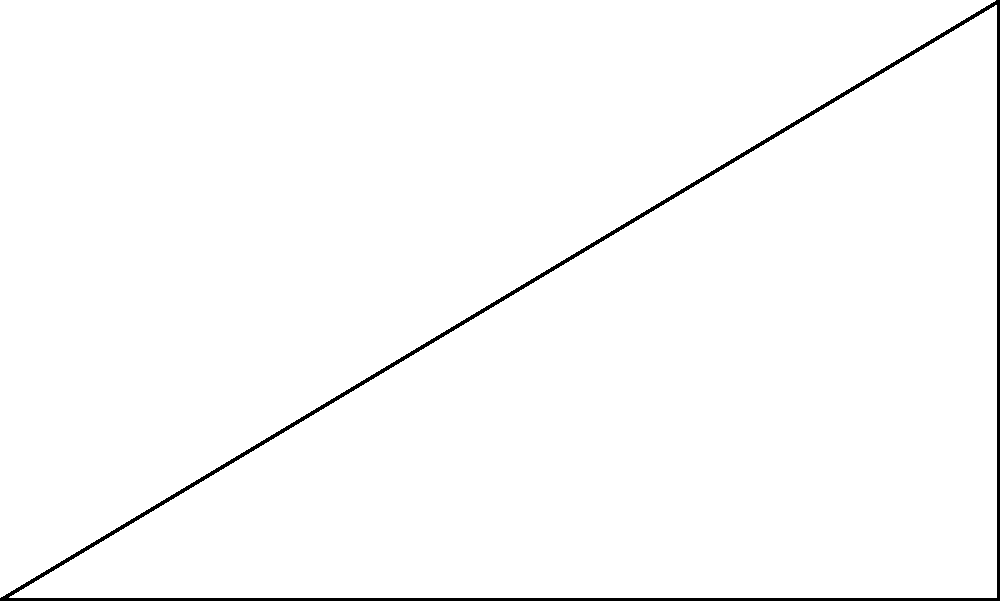You're visiting a location from a novel that describes a tall building. Standing 100 meters away from its base, you observe that the angle of elevation to the top of the building is the same as the one mentioned in the book. If the building is 60 meters tall, what is the angle of elevation (θ) to the top of the building from your viewpoint? To solve this problem, we can use trigonometry. Let's break it down step-by-step:

1) We have a right triangle with the following measurements:
   - The adjacent side (ground distance) is 100 meters
   - The opposite side (building height) is 60 meters
   - We need to find the angle θ

2) In a right triangle, tangent of an angle is the ratio of the opposite side to the adjacent side:

   $$\tan(\theta) = \frac{\text{opposite}}{\text{adjacent}}$$

3) Substituting our values:

   $$\tan(\theta) = \frac{60}{100} = 0.6$$

4) To find θ, we need to take the inverse tangent (arctan or tan^(-1)) of both sides:

   $$\theta = \tan^{-1}(0.6)$$

5) Using a calculator or mathematical tables:

   $$\theta \approx 30.96^\circ$$

6) Rounding to the nearest degree:

   $$\theta \approx 31^\circ$$

Therefore, the angle of elevation to the top of the building from your viewpoint is approximately 31°.
Answer: 31° 